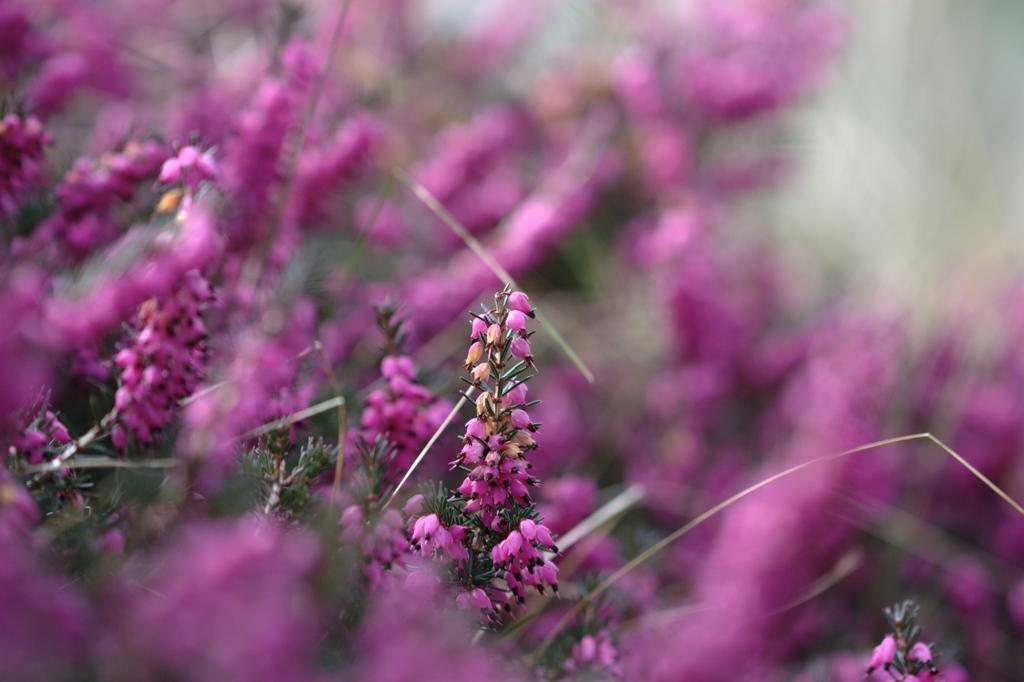What type of plants can be seen in the image? There are beautiful purple plants in the image. Is there anything special about one of the plants? One of the plants is highlighted. What type of drink is being served in the image? There is no drink present in the image; it only features beautiful purple plants. 